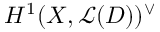Convert formula to latex. <formula><loc_0><loc_0><loc_500><loc_500>H ^ { 1 } ( X , { \mathcal { L } } ( D ) ) ^ { \vee }</formula> 